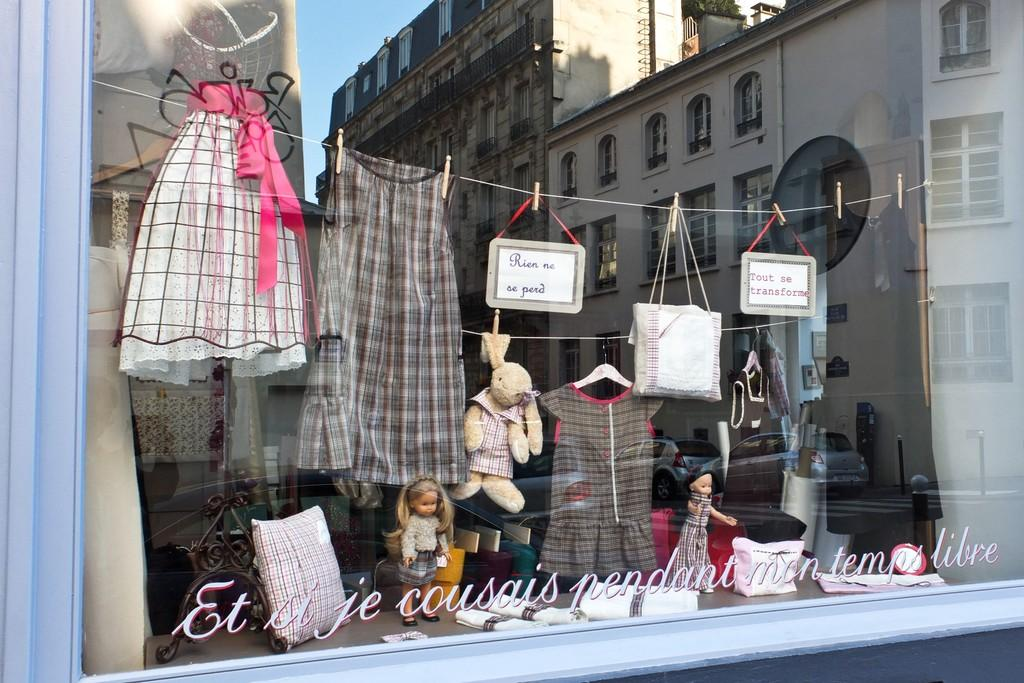What type of structures can be seen in the image? There are buildings in the image. What other objects are present in the image besides buildings? There are toys, a pillow, clothes, and bags in the image. What is visible at the top of the image? The sky is visible at the top of the image. How much fuel is required to power the toys in the image? There are no toys in the image that require fuel, as they are likely traditional toys that do not need power. 